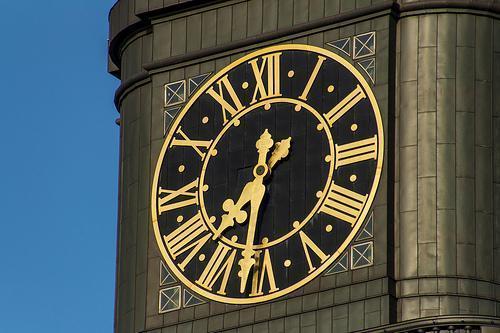How many squares around the clock?
Give a very brief answer. 4. 